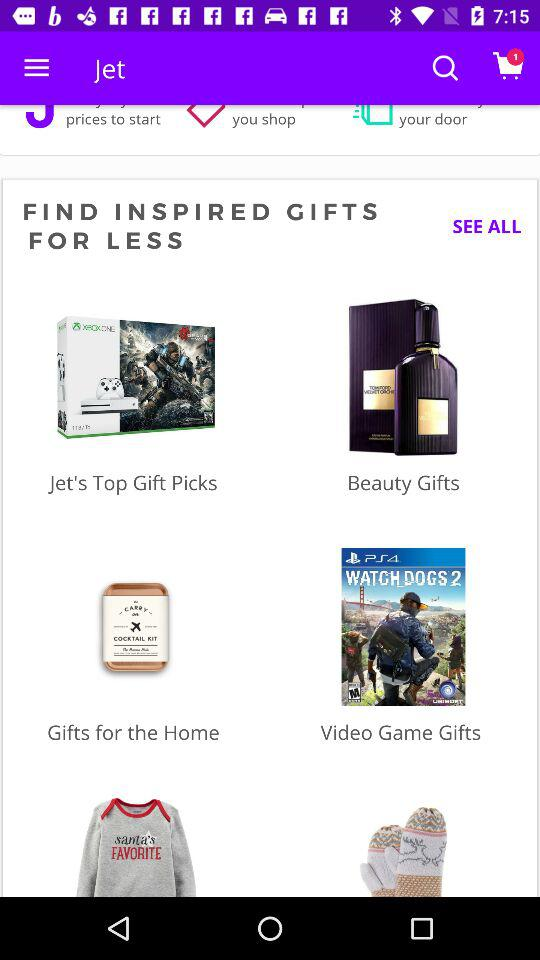How many items are in the cart? There is one item in the cart. 